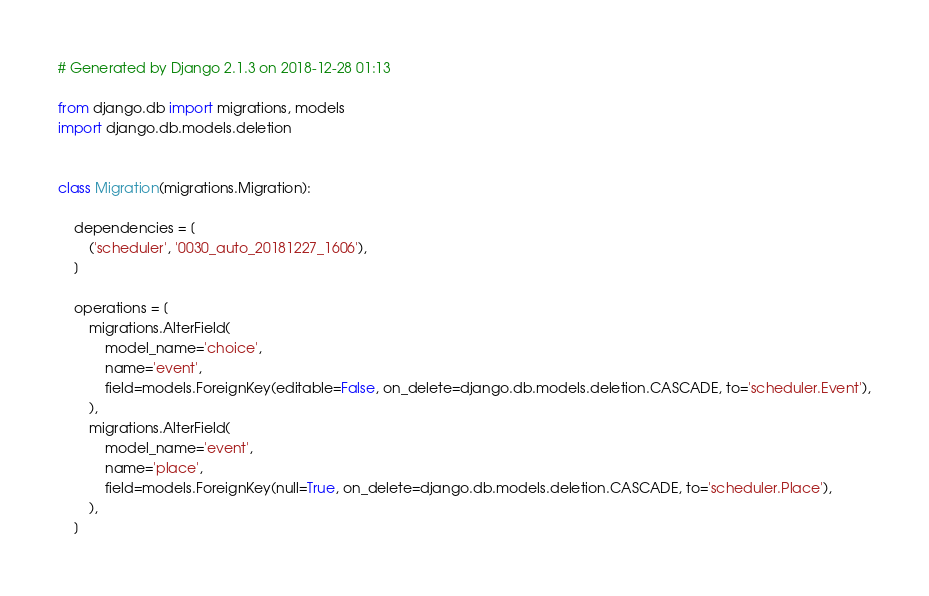Convert code to text. <code><loc_0><loc_0><loc_500><loc_500><_Python_># Generated by Django 2.1.3 on 2018-12-28 01:13

from django.db import migrations, models
import django.db.models.deletion


class Migration(migrations.Migration):

    dependencies = [
        ('scheduler', '0030_auto_20181227_1606'),
    ]

    operations = [
        migrations.AlterField(
            model_name='choice',
            name='event',
            field=models.ForeignKey(editable=False, on_delete=django.db.models.deletion.CASCADE, to='scheduler.Event'),
        ),
        migrations.AlterField(
            model_name='event',
            name='place',
            field=models.ForeignKey(null=True, on_delete=django.db.models.deletion.CASCADE, to='scheduler.Place'),
        ),
    ]
</code> 